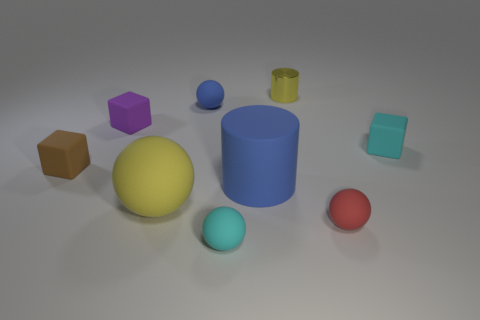Add 1 yellow balls. How many objects exist? 10 Subtract all cylinders. How many objects are left? 7 Add 9 brown blocks. How many brown blocks are left? 10 Add 9 big yellow things. How many big yellow things exist? 10 Subtract 1 blue balls. How many objects are left? 8 Subtract all large things. Subtract all purple rubber things. How many objects are left? 6 